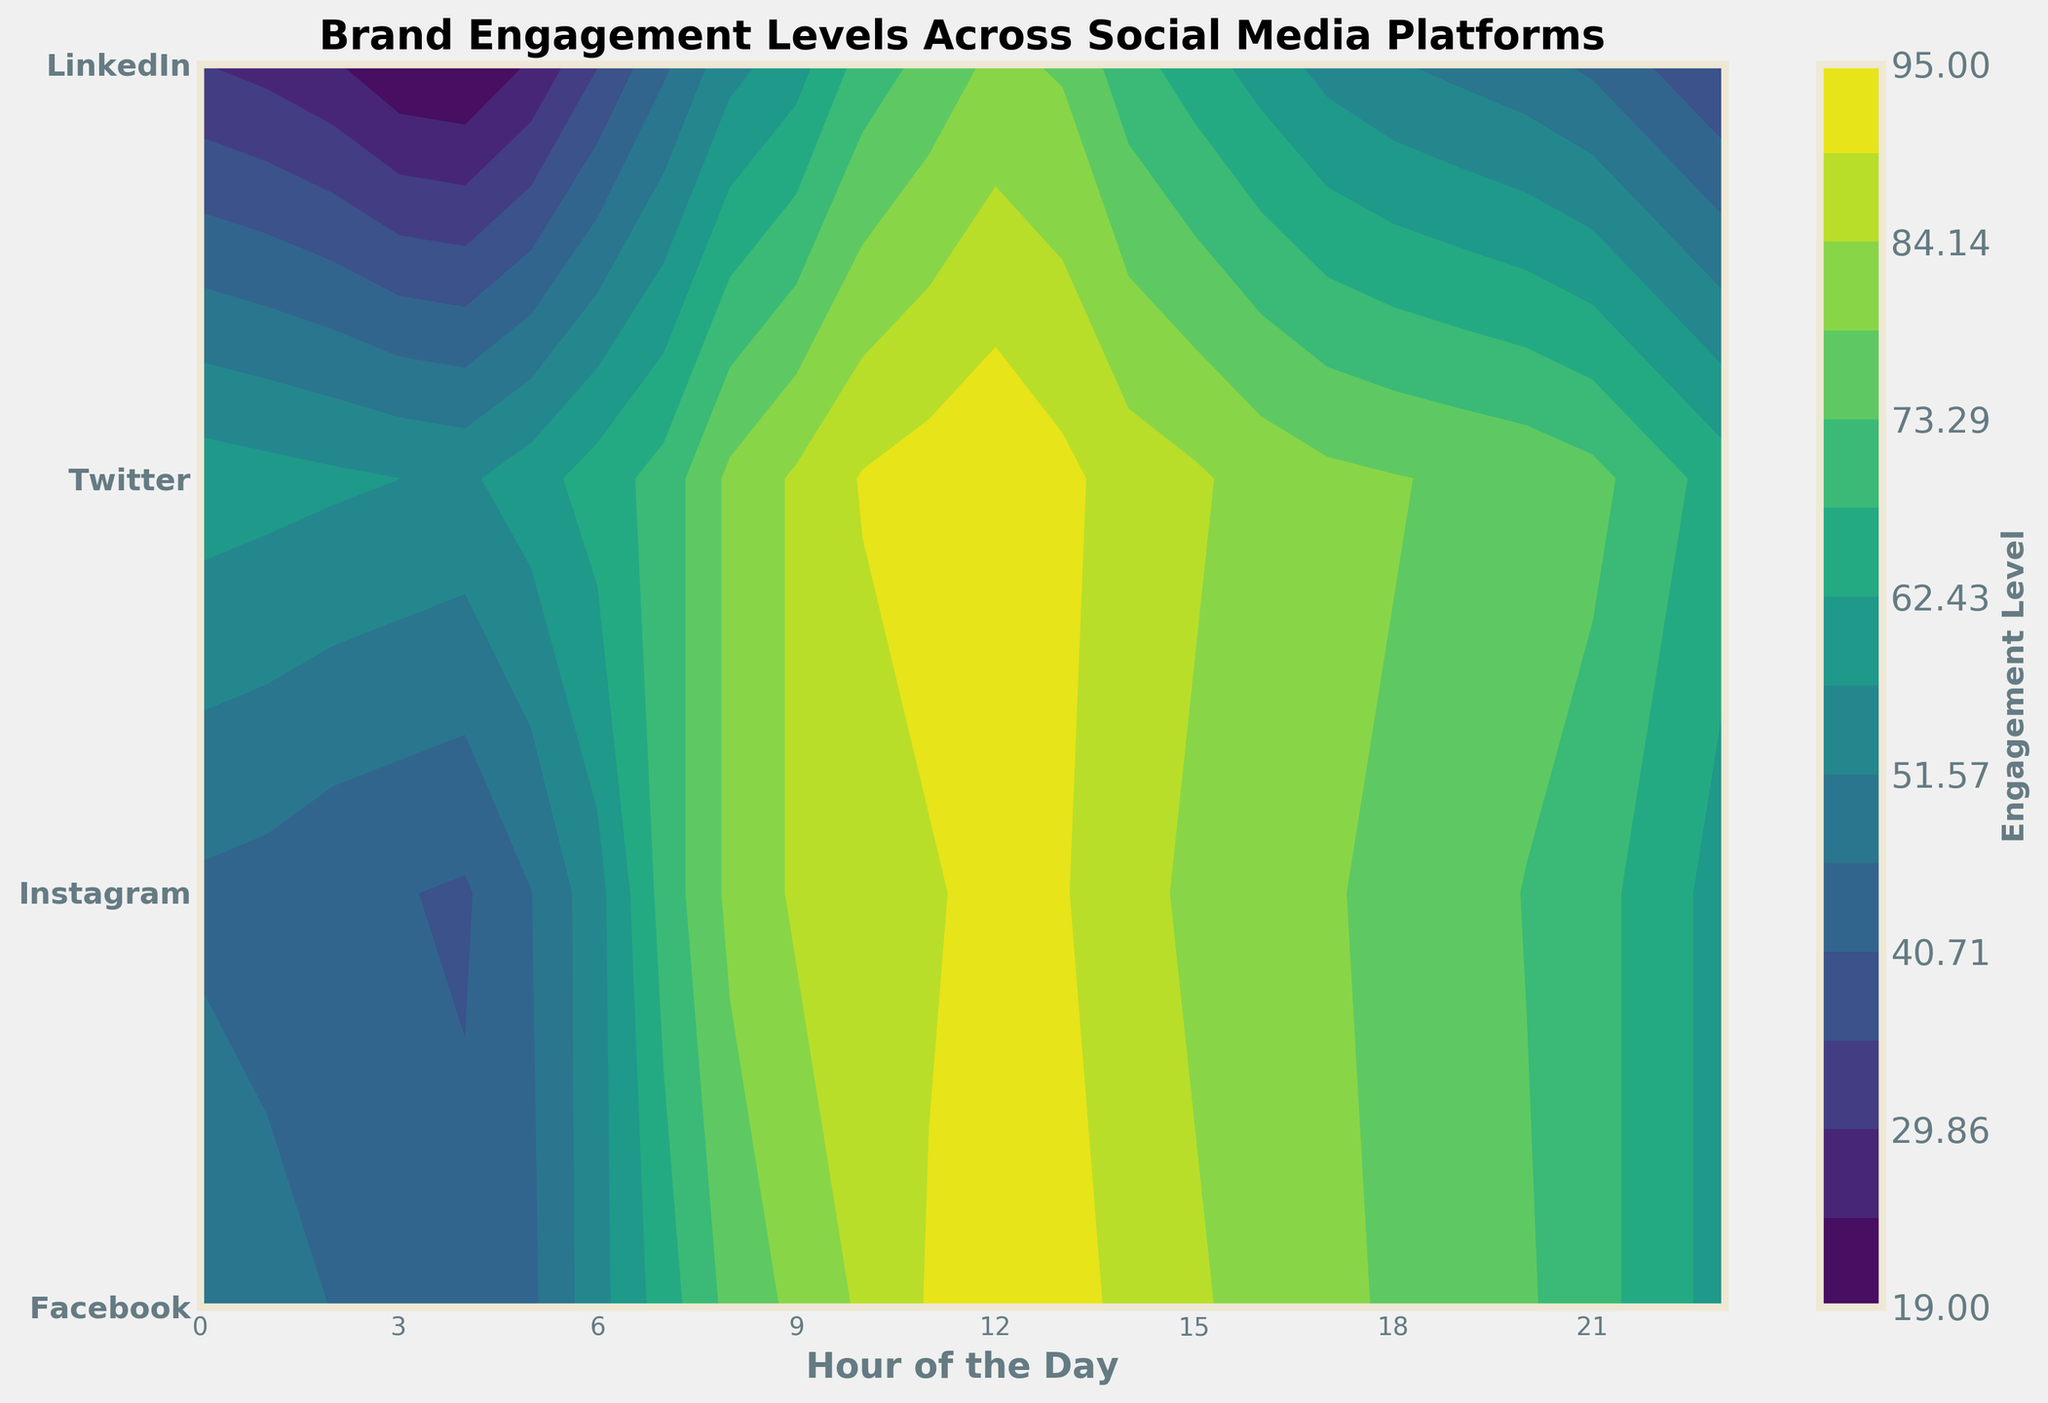What is the title of the figure? The title is located at the top center of the figure in bold text. It summarizes the plot's main subject.
Answer: Brand Engagement Levels Across Social Media Platforms What platforms are compared in the figure? The y-axis labels indicate the platforms being compared.
Answer: Facebook, Instagram, Twitter, LinkedIn What is the engagement level on Instagram at 12 PM? Locate the contour level at 12 PM along the Instagram band on the y-axis to find the engagement level.
Answer: 91 Between which hours does Facebook have the highest engagement level? Observe the contour colors along the Facebook band and note the hours where the engagement level is highest.
Answer: 10 AM to 12 PM Which platform has the lowest engagement at 3 AM? Identify the contour level at 3 AM across all platforms and find the lowest value.
Answer: LinkedIn Which platform shows the steepest increase in engagement level between 6 AM to 9 AM? Compare the contour gradient changes between 6 AM to 9 AM across all platforms to determine the steepest increase.
Answer: Instagram How does Twitter's engagement at 8 PM compare to Facebook's engagement at 8 PM? Check the contour levels at 8 PM for both Twitter and Facebook and compare the values.
Answer: Twitter is higher What is the average engagement level for LinkedIn between 6 AM and 12 PM? Sum the LinkedIn engagement levels between 6 AM and 12 PM and divide by the number of hours (7).
Answer: 54.3 Which platform has the most consistent engagement level throughout the day? Analyze the contour smoothness for each platform to identify the most consistent pattern.
Answer: LinkedIn 